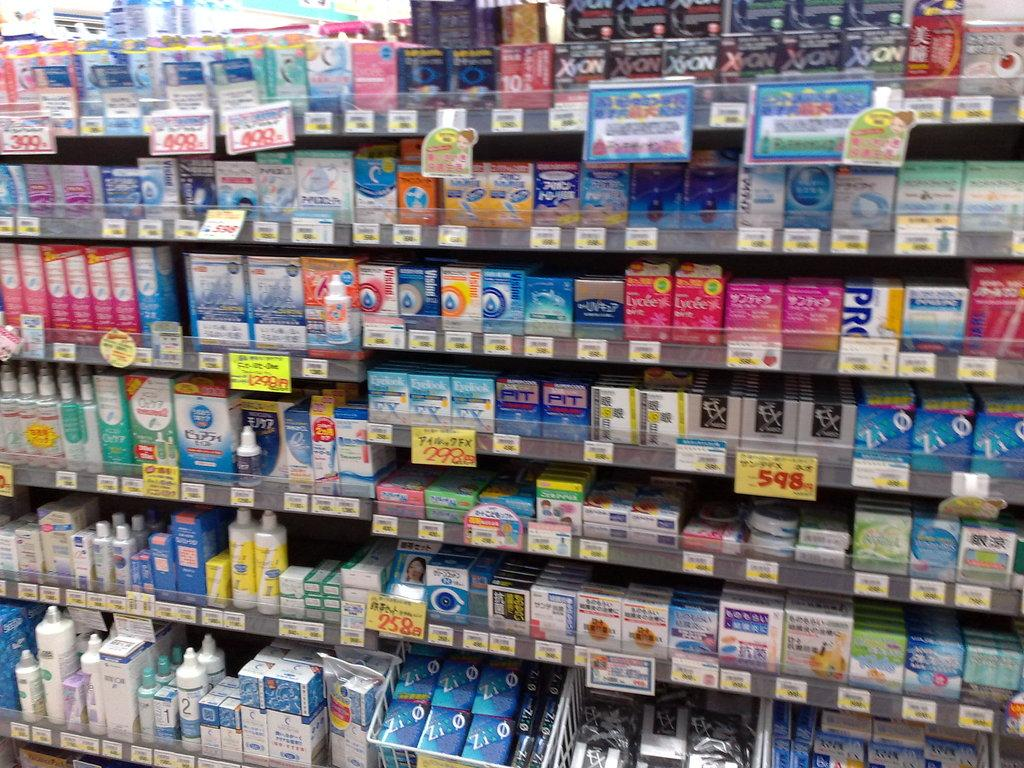What types of items are visible on the shelves in the image? There are different kinds of cartons and containers arranged on shelves in the image. What can be found on the information boards in the image? The information boards in the image provide details about the cartons and containers. What type of honey is being sold in the image? There is no honey visible in the image; it features cartons and containers arranged on shelves. How many buns are stacked on the shelves in the image? There are no buns present in the image; it features cartons and containers arranged on shelves. 